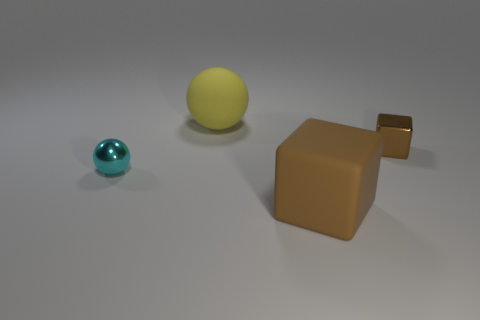Add 1 brown rubber cubes. How many objects exist? 5 Add 1 blue things. How many blue things exist? 1 Subtract 0 gray cylinders. How many objects are left? 4 Subtract all large yellow objects. Subtract all small brown shiny objects. How many objects are left? 2 Add 2 brown blocks. How many brown blocks are left? 4 